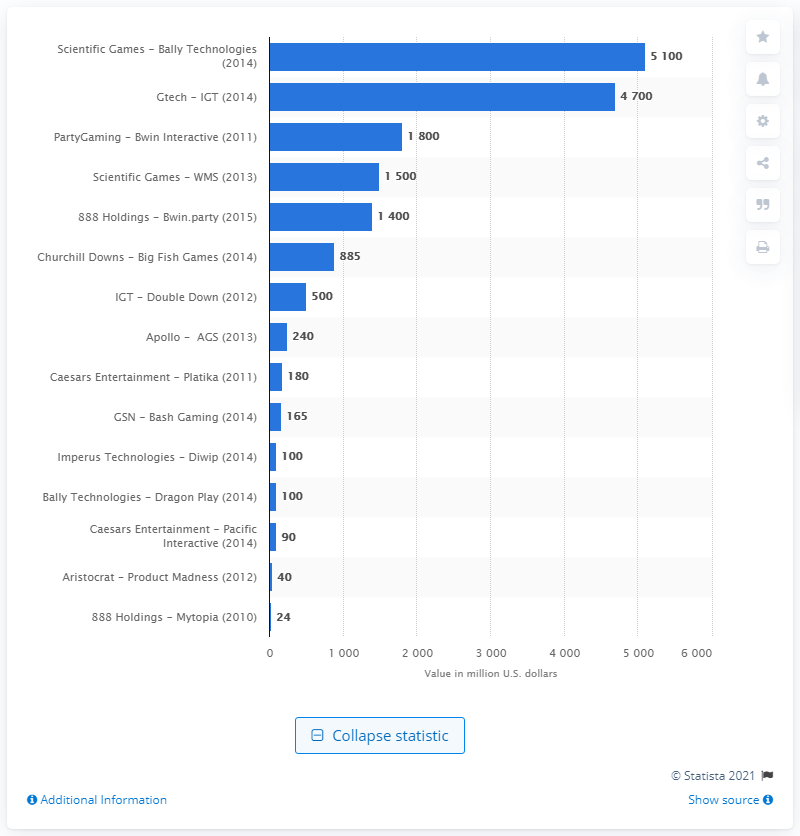Highlight a few significant elements in this photo. I'm sorry, but I'm not sure what you are asking. Could you please provide more context or clarify your question? 